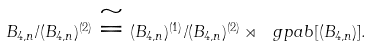<formula> <loc_0><loc_0><loc_500><loc_500>B _ { 4 , n } / ( B _ { 4 , n } ) ^ { ( 2 ) } \cong ( B _ { 4 , n } ) ^ { ( 1 ) } / ( B _ { 4 , n } ) ^ { ( 2 ) } \rtimes \ g p a b [ ( B _ { 4 , n } ) ] .</formula> 